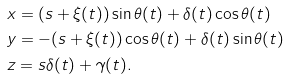<formula> <loc_0><loc_0><loc_500><loc_500>& x = ( s + \xi ( t ) ) \sin \theta ( t ) + \delta ( t ) \cos \theta ( t ) & \\ & y = - ( s + \xi ( t ) ) \cos \theta ( t ) + \delta ( t ) \sin \theta ( t ) & \\ & z = s \delta ( t ) + \gamma ( t ) . &</formula> 